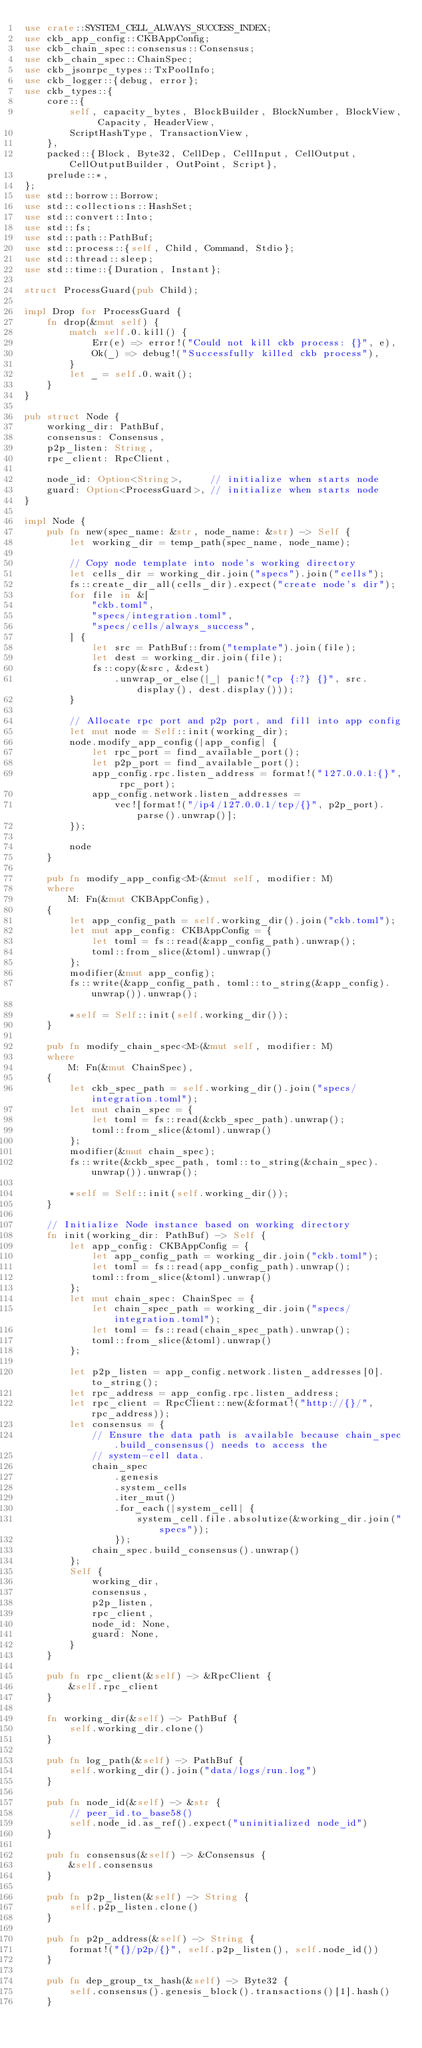Convert code to text. <code><loc_0><loc_0><loc_500><loc_500><_Rust_>use crate::SYSTEM_CELL_ALWAYS_SUCCESS_INDEX;
use ckb_app_config::CKBAppConfig;
use ckb_chain_spec::consensus::Consensus;
use ckb_chain_spec::ChainSpec;
use ckb_jsonrpc_types::TxPoolInfo;
use ckb_logger::{debug, error};
use ckb_types::{
    core::{
        self, capacity_bytes, BlockBuilder, BlockNumber, BlockView, Capacity, HeaderView,
        ScriptHashType, TransactionView,
    },
    packed::{Block, Byte32, CellDep, CellInput, CellOutput, CellOutputBuilder, OutPoint, Script},
    prelude::*,
};
use std::borrow::Borrow;
use std::collections::HashSet;
use std::convert::Into;
use std::fs;
use std::path::PathBuf;
use std::process::{self, Child, Command, Stdio};
use std::thread::sleep;
use std::time::{Duration, Instant};

struct ProcessGuard(pub Child);

impl Drop for ProcessGuard {
    fn drop(&mut self) {
        match self.0.kill() {
            Err(e) => error!("Could not kill ckb process: {}", e),
            Ok(_) => debug!("Successfully killed ckb process"),
        }
        let _ = self.0.wait();
    }
}

pub struct Node {
    working_dir: PathBuf,
    consensus: Consensus,
    p2p_listen: String,
    rpc_client: RpcClient,

    node_id: Option<String>,     // initialize when starts node
    guard: Option<ProcessGuard>, // initialize when starts node
}

impl Node {
    pub fn new(spec_name: &str, node_name: &str) -> Self {
        let working_dir = temp_path(spec_name, node_name);

        // Copy node template into node's working directory
        let cells_dir = working_dir.join("specs").join("cells");
        fs::create_dir_all(cells_dir).expect("create node's dir");
        for file in &[
            "ckb.toml",
            "specs/integration.toml",
            "specs/cells/always_success",
        ] {
            let src = PathBuf::from("template").join(file);
            let dest = working_dir.join(file);
            fs::copy(&src, &dest)
                .unwrap_or_else(|_| panic!("cp {:?} {}", src.display(), dest.display()));
        }

        // Allocate rpc port and p2p port, and fill into app config
        let mut node = Self::init(working_dir);
        node.modify_app_config(|app_config| {
            let rpc_port = find_available_port();
            let p2p_port = find_available_port();
            app_config.rpc.listen_address = format!("127.0.0.1:{}", rpc_port);
            app_config.network.listen_addresses =
                vec![format!("/ip4/127.0.0.1/tcp/{}", p2p_port).parse().unwrap()];
        });

        node
    }

    pub fn modify_app_config<M>(&mut self, modifier: M)
    where
        M: Fn(&mut CKBAppConfig),
    {
        let app_config_path = self.working_dir().join("ckb.toml");
        let mut app_config: CKBAppConfig = {
            let toml = fs::read(&app_config_path).unwrap();
            toml::from_slice(&toml).unwrap()
        };
        modifier(&mut app_config);
        fs::write(&app_config_path, toml::to_string(&app_config).unwrap()).unwrap();

        *self = Self::init(self.working_dir());
    }

    pub fn modify_chain_spec<M>(&mut self, modifier: M)
    where
        M: Fn(&mut ChainSpec),
    {
        let ckb_spec_path = self.working_dir().join("specs/integration.toml");
        let mut chain_spec = {
            let toml = fs::read(&ckb_spec_path).unwrap();
            toml::from_slice(&toml).unwrap()
        };
        modifier(&mut chain_spec);
        fs::write(&ckb_spec_path, toml::to_string(&chain_spec).unwrap()).unwrap();

        *self = Self::init(self.working_dir());
    }

    // Initialize Node instance based on working directory
    fn init(working_dir: PathBuf) -> Self {
        let app_config: CKBAppConfig = {
            let app_config_path = working_dir.join("ckb.toml");
            let toml = fs::read(app_config_path).unwrap();
            toml::from_slice(&toml).unwrap()
        };
        let mut chain_spec: ChainSpec = {
            let chain_spec_path = working_dir.join("specs/integration.toml");
            let toml = fs::read(chain_spec_path).unwrap();
            toml::from_slice(&toml).unwrap()
        };

        let p2p_listen = app_config.network.listen_addresses[0].to_string();
        let rpc_address = app_config.rpc.listen_address;
        let rpc_client = RpcClient::new(&format!("http://{}/", rpc_address));
        let consensus = {
            // Ensure the data path is available because chain_spec.build_consensus() needs to access the
            // system-cell data.
            chain_spec
                .genesis
                .system_cells
                .iter_mut()
                .for_each(|system_cell| {
                    system_cell.file.absolutize(&working_dir.join("specs"));
                });
            chain_spec.build_consensus().unwrap()
        };
        Self {
            working_dir,
            consensus,
            p2p_listen,
            rpc_client,
            node_id: None,
            guard: None,
        }
    }

    pub fn rpc_client(&self) -> &RpcClient {
        &self.rpc_client
    }

    fn working_dir(&self) -> PathBuf {
        self.working_dir.clone()
    }

    pub fn log_path(&self) -> PathBuf {
        self.working_dir().join("data/logs/run.log")
    }

    pub fn node_id(&self) -> &str {
        // peer_id.to_base58()
        self.node_id.as_ref().expect("uninitialized node_id")
    }

    pub fn consensus(&self) -> &Consensus {
        &self.consensus
    }

    pub fn p2p_listen(&self) -> String {
        self.p2p_listen.clone()
    }

    pub fn p2p_address(&self) -> String {
        format!("{}/p2p/{}", self.p2p_listen(), self.node_id())
    }

    pub fn dep_group_tx_hash(&self) -> Byte32 {
        self.consensus().genesis_block().transactions()[1].hash()
    }
</code> 